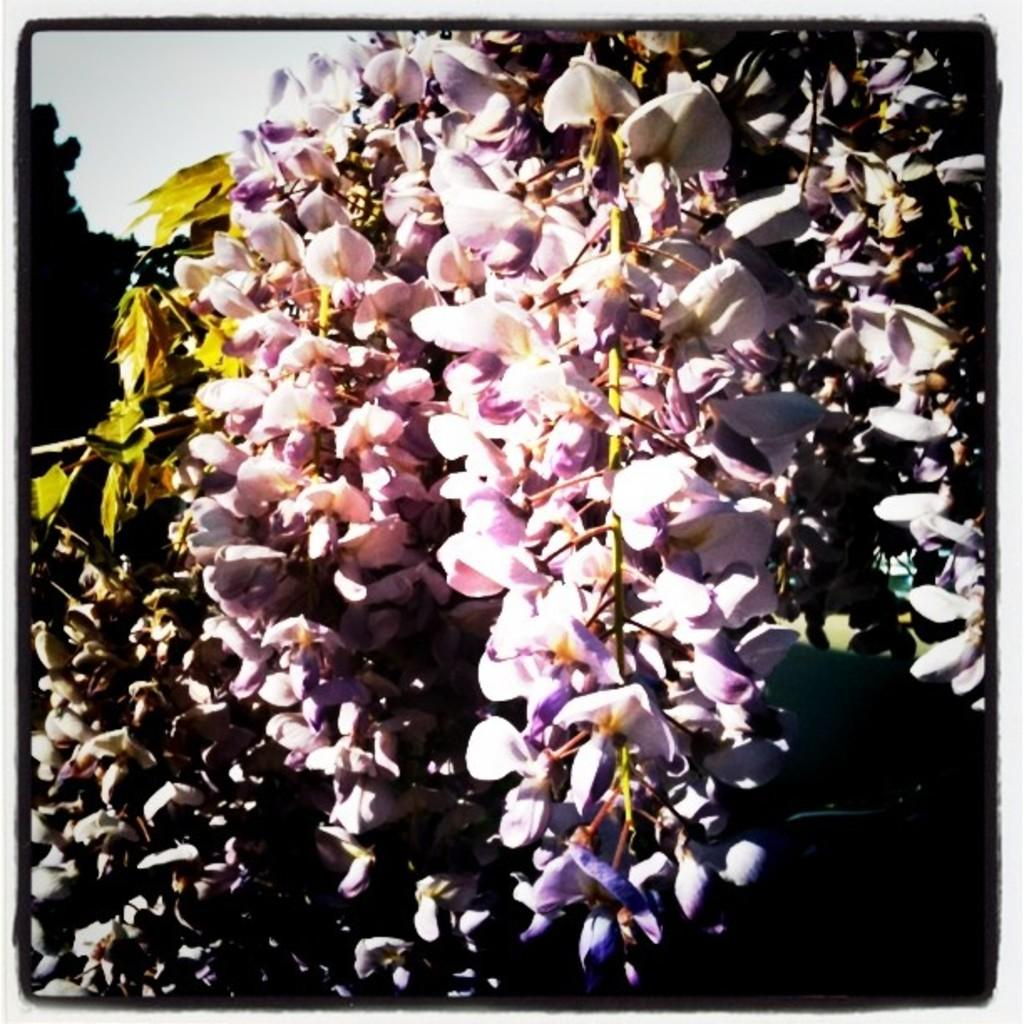What is located in the foreground of the image? There are flowers in the foreground of the image. What can be seen in the background of the image? There is a tree and the sky visible in the background of the image. Reasoning: Let's think step by identifying the main subjects and objects in the image based on the provided facts. We then formulate questions that focus on the location and characteristics of these subjects and objects, ensuring that each question can be answered definitively with the information given. We avoid yes/no questions and ensure that the language is simple and clear. Absurd Question/Answer: How many bottles are being used by the police in the image? There is no reference to any bottles or police in the image; it features flowers in the foreground and a tree and sky in the background. How many balls are being juggled by the police in the image? There is no reference to any balls or police in the image; it features flowers in the foreground and a tree and sky in the background. 